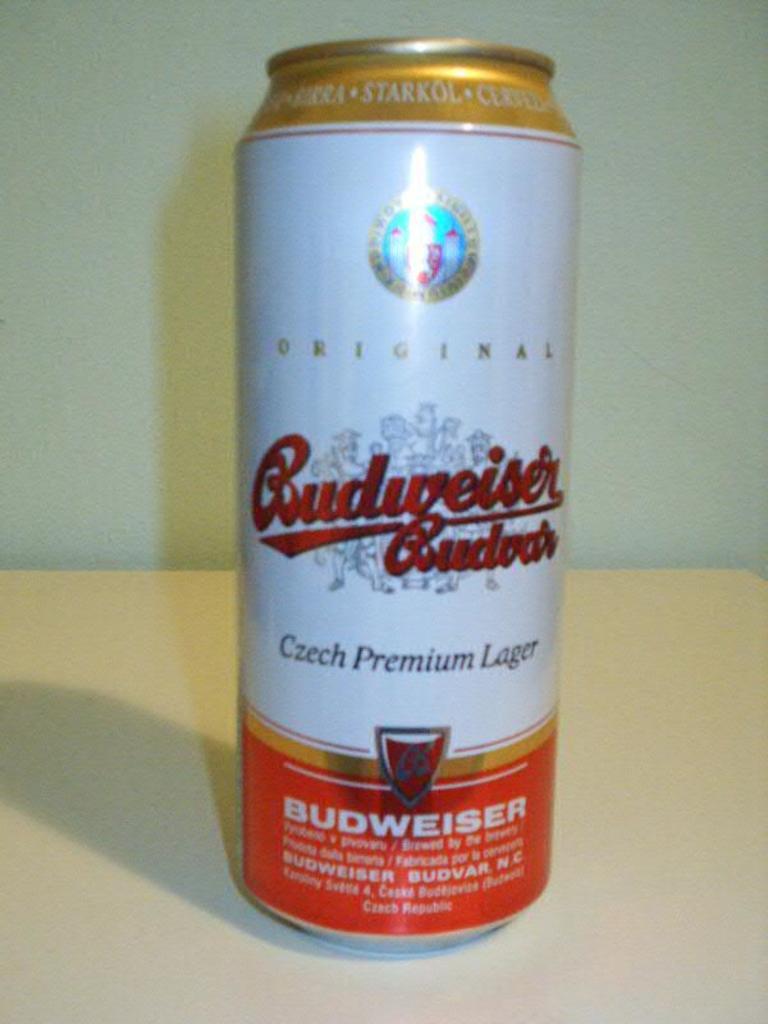Who made this beer?
Make the answer very short. Budweiser. 